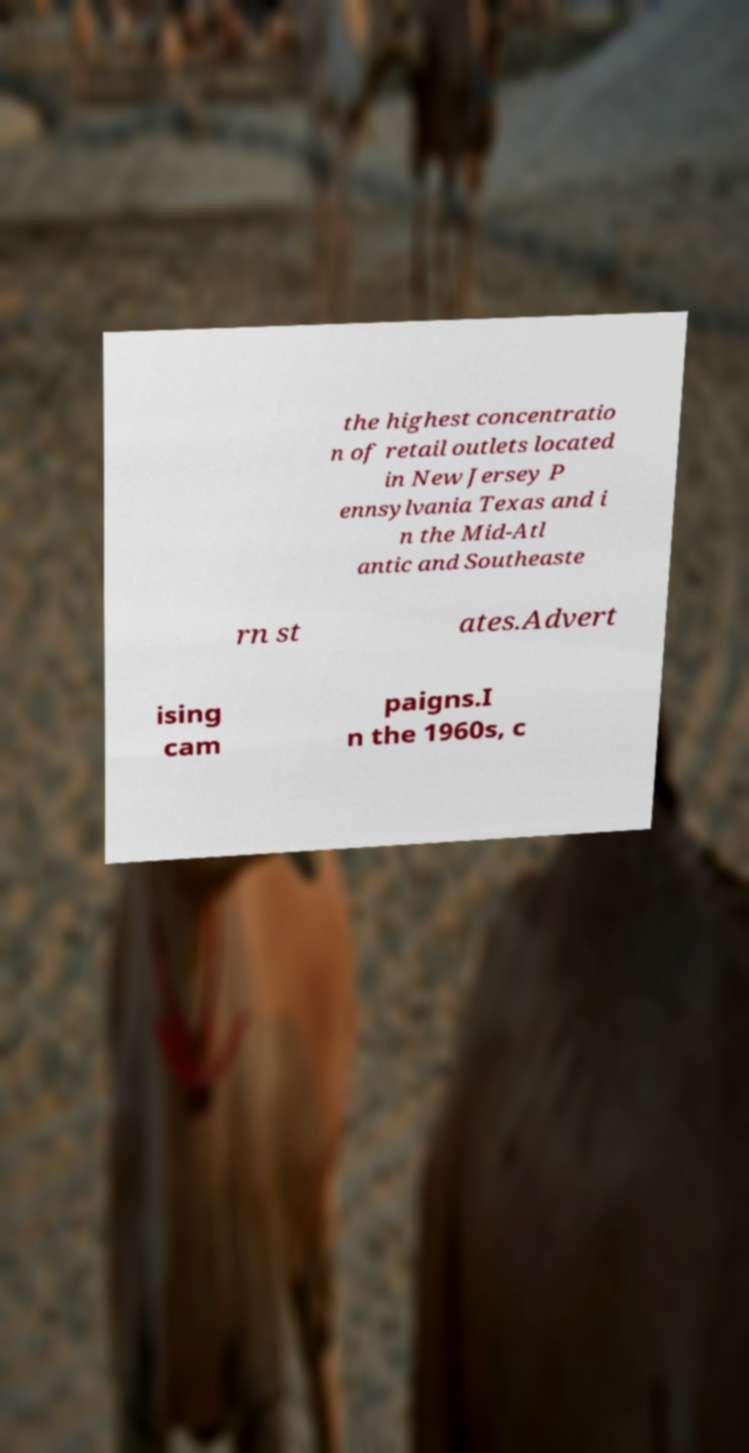Could you assist in decoding the text presented in this image and type it out clearly? the highest concentratio n of retail outlets located in New Jersey P ennsylvania Texas and i n the Mid-Atl antic and Southeaste rn st ates.Advert ising cam paigns.I n the 1960s, c 